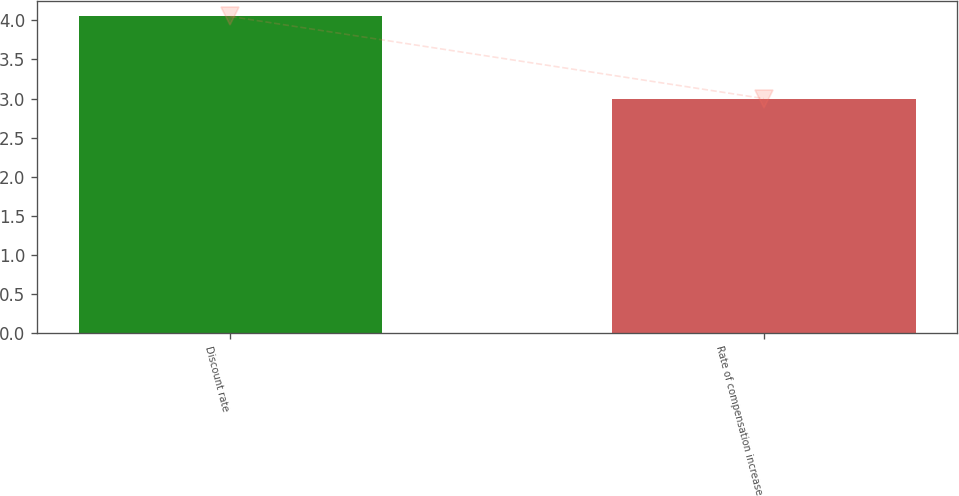Convert chart to OTSL. <chart><loc_0><loc_0><loc_500><loc_500><bar_chart><fcel>Discount rate<fcel>Rate of compensation increase<nl><fcel>4.05<fcel>3<nl></chart> 